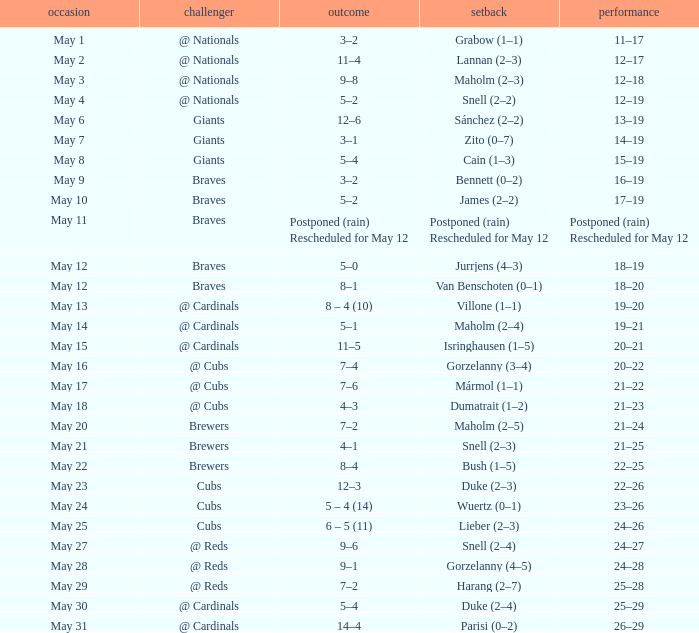Who was the opponent at the game with a score of 7–6? @ Cubs. 